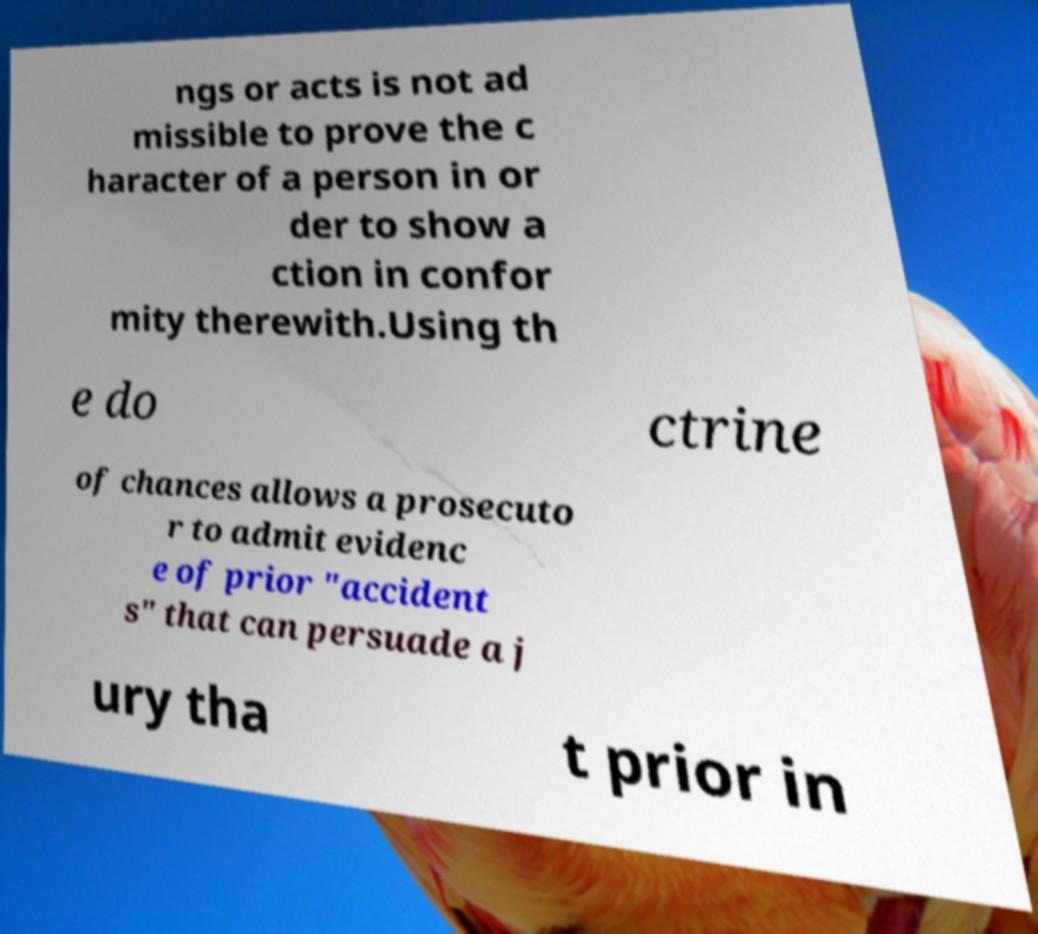What messages or text are displayed in this image? I need them in a readable, typed format. ngs or acts is not ad missible to prove the c haracter of a person in or der to show a ction in confor mity therewith.Using th e do ctrine of chances allows a prosecuto r to admit evidenc e of prior "accident s" that can persuade a j ury tha t prior in 